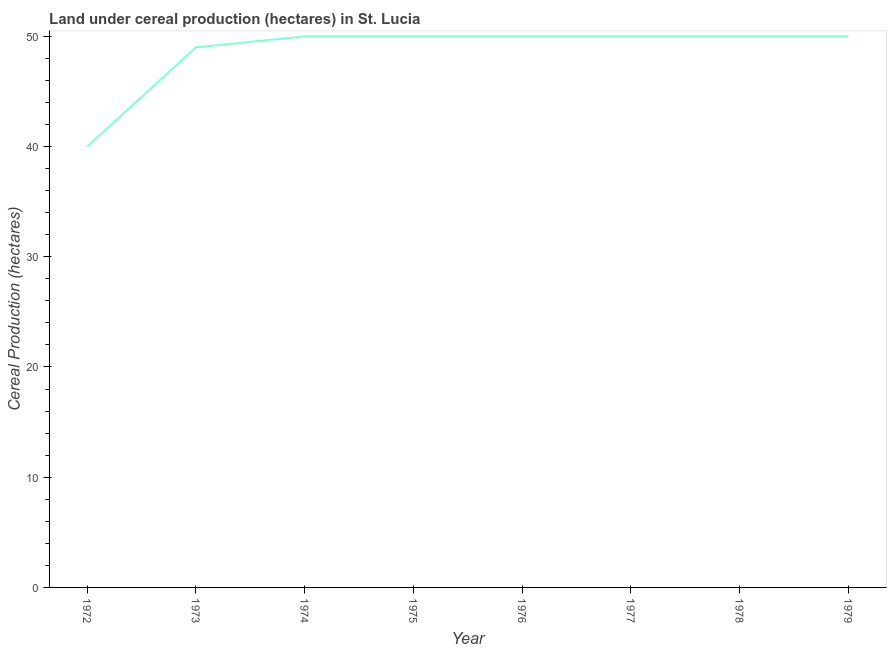What is the land under cereal production in 1978?
Give a very brief answer. 50. Across all years, what is the maximum land under cereal production?
Keep it short and to the point. 50. Across all years, what is the minimum land under cereal production?
Keep it short and to the point. 40. In which year was the land under cereal production maximum?
Keep it short and to the point. 1974. In which year was the land under cereal production minimum?
Your response must be concise. 1972. What is the sum of the land under cereal production?
Offer a very short reply. 389. What is the average land under cereal production per year?
Provide a short and direct response. 48.62. What is the median land under cereal production?
Provide a succinct answer. 50. In how many years, is the land under cereal production greater than 36 hectares?
Your answer should be compact. 8. What is the ratio of the land under cereal production in 1972 to that in 1977?
Offer a very short reply. 0.8. Is the difference between the land under cereal production in 1972 and 1976 greater than the difference between any two years?
Your answer should be compact. Yes. What is the difference between the highest and the lowest land under cereal production?
Offer a terse response. 10. In how many years, is the land under cereal production greater than the average land under cereal production taken over all years?
Your answer should be compact. 7. Does the land under cereal production monotonically increase over the years?
Your answer should be very brief. No. How many lines are there?
Your response must be concise. 1. How many years are there in the graph?
Offer a very short reply. 8. Are the values on the major ticks of Y-axis written in scientific E-notation?
Offer a very short reply. No. What is the title of the graph?
Offer a very short reply. Land under cereal production (hectares) in St. Lucia. What is the label or title of the Y-axis?
Give a very brief answer. Cereal Production (hectares). What is the Cereal Production (hectares) in 1973?
Your answer should be very brief. 49. What is the Cereal Production (hectares) in 1974?
Keep it short and to the point. 50. What is the Cereal Production (hectares) of 1975?
Give a very brief answer. 50. What is the Cereal Production (hectares) in 1976?
Offer a terse response. 50. What is the Cereal Production (hectares) of 1979?
Your answer should be compact. 50. What is the difference between the Cereal Production (hectares) in 1972 and 1975?
Your answer should be compact. -10. What is the difference between the Cereal Production (hectares) in 1972 and 1977?
Provide a succinct answer. -10. What is the difference between the Cereal Production (hectares) in 1972 and 1978?
Keep it short and to the point. -10. What is the difference between the Cereal Production (hectares) in 1972 and 1979?
Provide a short and direct response. -10. What is the difference between the Cereal Production (hectares) in 1973 and 1974?
Provide a short and direct response. -1. What is the difference between the Cereal Production (hectares) in 1973 and 1976?
Make the answer very short. -1. What is the difference between the Cereal Production (hectares) in 1973 and 1978?
Offer a terse response. -1. What is the difference between the Cereal Production (hectares) in 1973 and 1979?
Your answer should be very brief. -1. What is the difference between the Cereal Production (hectares) in 1974 and 1977?
Make the answer very short. 0. What is the difference between the Cereal Production (hectares) in 1974 and 1978?
Your response must be concise. 0. What is the difference between the Cereal Production (hectares) in 1974 and 1979?
Your answer should be compact. 0. What is the difference between the Cereal Production (hectares) in 1975 and 1978?
Provide a short and direct response. 0. What is the difference between the Cereal Production (hectares) in 1976 and 1979?
Your response must be concise. 0. What is the difference between the Cereal Production (hectares) in 1977 and 1978?
Ensure brevity in your answer.  0. What is the difference between the Cereal Production (hectares) in 1977 and 1979?
Provide a succinct answer. 0. What is the difference between the Cereal Production (hectares) in 1978 and 1979?
Your answer should be compact. 0. What is the ratio of the Cereal Production (hectares) in 1972 to that in 1973?
Offer a very short reply. 0.82. What is the ratio of the Cereal Production (hectares) in 1972 to that in 1975?
Provide a short and direct response. 0.8. What is the ratio of the Cereal Production (hectares) in 1972 to that in 1977?
Offer a very short reply. 0.8. What is the ratio of the Cereal Production (hectares) in 1972 to that in 1979?
Your answer should be very brief. 0.8. What is the ratio of the Cereal Production (hectares) in 1973 to that in 1974?
Your answer should be compact. 0.98. What is the ratio of the Cereal Production (hectares) in 1973 to that in 1977?
Your answer should be compact. 0.98. What is the ratio of the Cereal Production (hectares) in 1973 to that in 1978?
Offer a very short reply. 0.98. What is the ratio of the Cereal Production (hectares) in 1974 to that in 1977?
Ensure brevity in your answer.  1. What is the ratio of the Cereal Production (hectares) in 1974 to that in 1978?
Your response must be concise. 1. What is the ratio of the Cereal Production (hectares) in 1975 to that in 1976?
Offer a very short reply. 1. What is the ratio of the Cereal Production (hectares) in 1975 to that in 1978?
Keep it short and to the point. 1. What is the ratio of the Cereal Production (hectares) in 1976 to that in 1978?
Provide a short and direct response. 1. What is the ratio of the Cereal Production (hectares) in 1977 to that in 1978?
Provide a succinct answer. 1. What is the ratio of the Cereal Production (hectares) in 1978 to that in 1979?
Offer a very short reply. 1. 